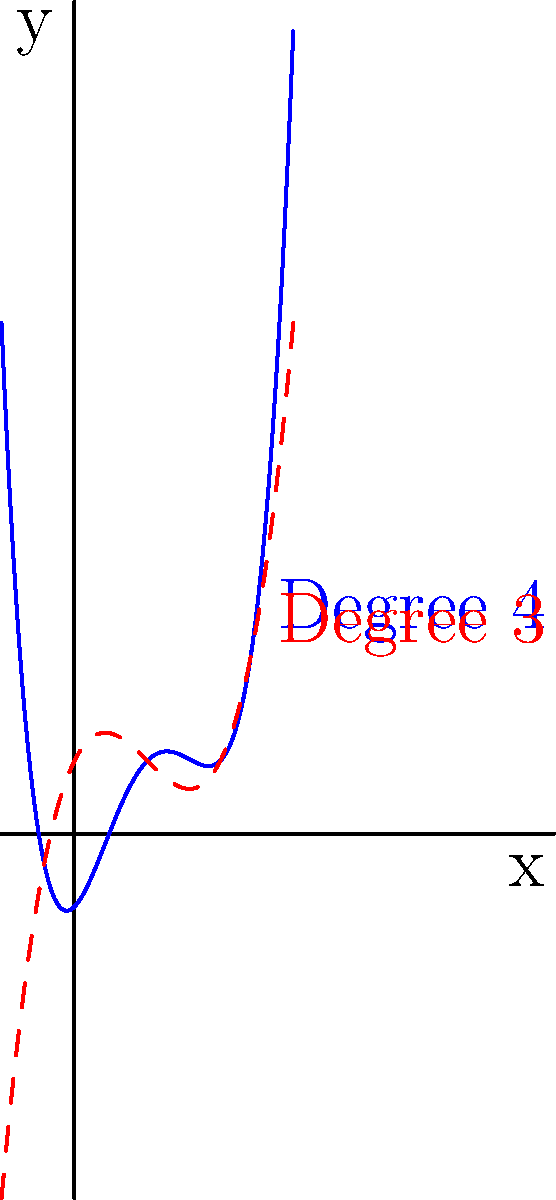As a mobile app developer working with Windows Phone 8 SDK, you're designing a graphing calculator app. You need to implement a feature that predicts the maximum number of turning points for polynomials of different degrees. Based on the graph shown, which depicts polynomials of degree 3 and 4, what is the relationship between a polynomial's degree $n$ and the maximum number of turning points in its graph? To determine the relationship between a polynomial's degree and its maximum number of turning points, let's analyze the problem step-by-step:

1. Observe the graphs:
   - The blue solid line represents a polynomial of degree 4.
   - The red dashed line represents a polynomial of degree 3.

2. Count the turning points:
   - The degree 4 polynomial has 3 turning points.
   - The degree 3 polynomial has 2 turning points.

3. Recall the mathematical relationship:
   - For a polynomial of degree $n$, the maximum number of turning points is $n-1$.

4. Verify this relationship with our observations:
   - For degree 4: Maximum turning points = 4 - 1 = 3 (matches the blue graph)
   - For degree 3: Maximum turning points = 3 - 1 = 2 (matches the red graph)

5. Generalize the relationship:
   - For any polynomial of degree $n$, the maximum number of turning points is always $n-1$.

This relationship holds because the number of turning points is related to the number of times the derivative of the polynomial can change sign, which is at most one less than the degree of the polynomial.
Answer: Maximum turning points = $n-1$, where $n$ is the polynomial's degree. 